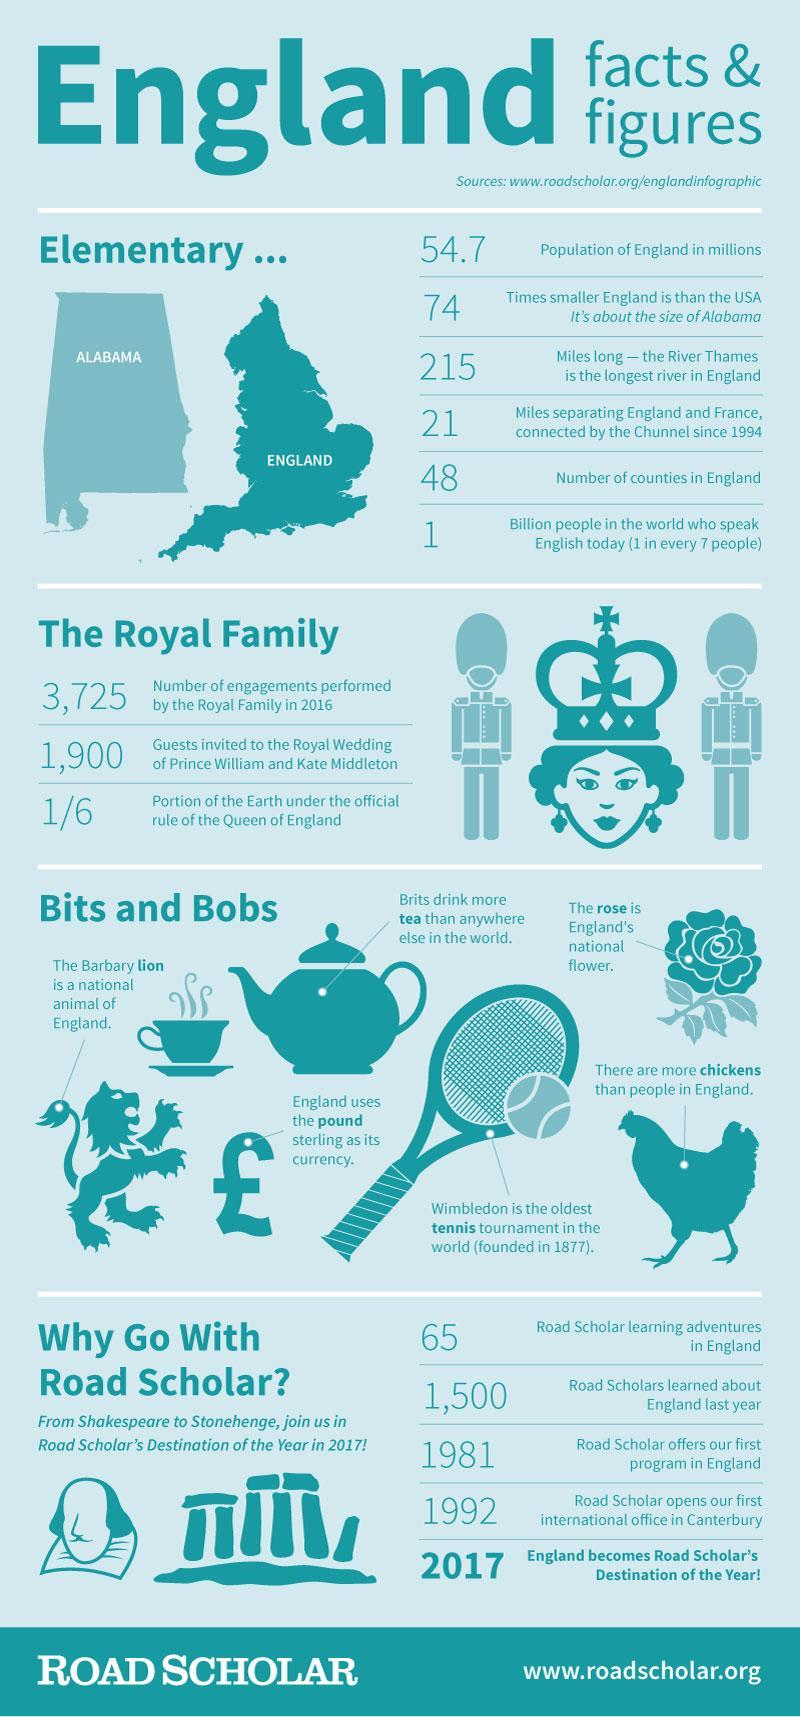The size of England is compared to which US state?
Answer the question with a short phrase. Alabama What is the national flower of England? Rose What portion of the Earth is under the official rule of the Queen of England? 1/6 Which is the oldest Tennis tournament in the world? Wimbledon What is the currency of England? Pound Sterling What is the total number of counties in England? 48 Which is the favourite drink of the Brits? Tea What is the estimated number of people across the world who speak English today? 1 Billion What is the national animal of England? The Barbary Lion What is the population of England? 54.7 Million 